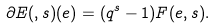<formula> <loc_0><loc_0><loc_500><loc_500>\partial E ( , s ) ( e ) = ( q ^ { s } - 1 ) F ( e , s ) .</formula> 